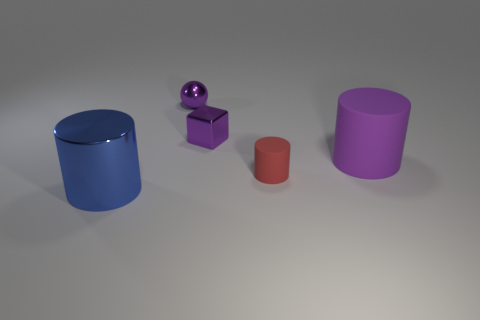Add 4 purple rubber cylinders. How many objects exist? 9 Subtract all spheres. How many objects are left? 4 Add 2 small purple shiny objects. How many small purple shiny objects are left? 4 Add 1 large red metal blocks. How many large red metal blocks exist? 1 Subtract 0 cyan spheres. How many objects are left? 5 Subtract all tiny cyan cubes. Subtract all metal cubes. How many objects are left? 4 